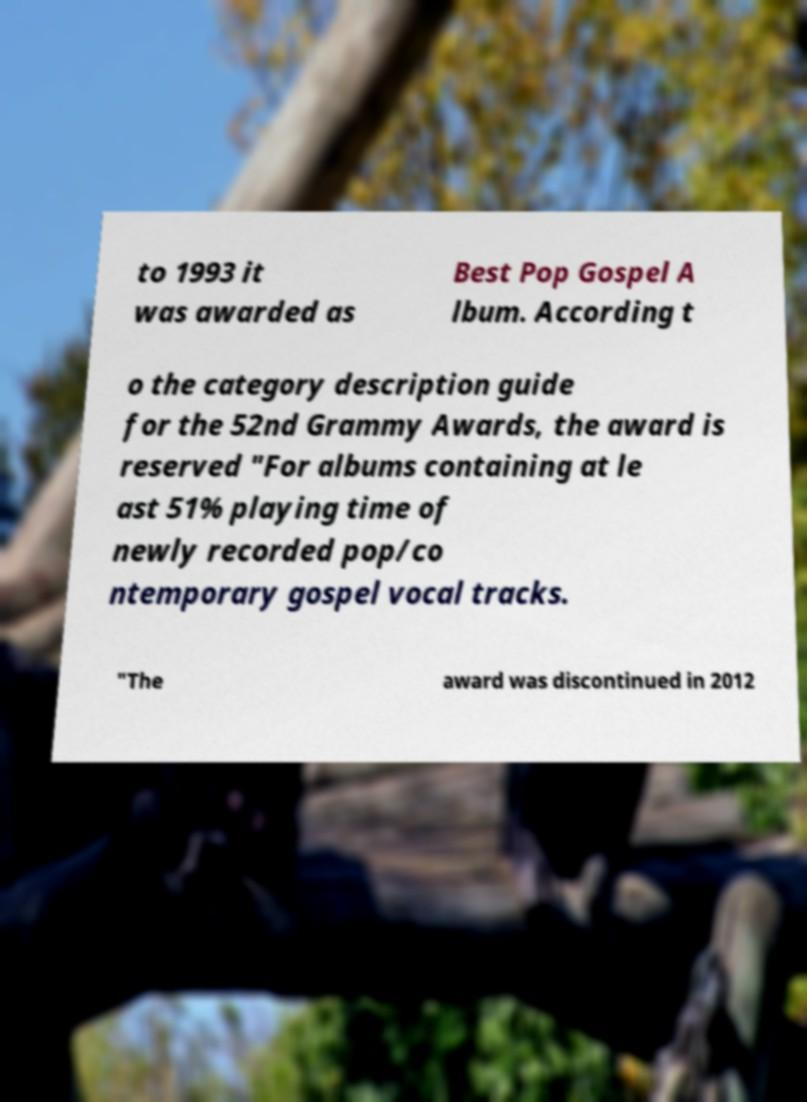I need the written content from this picture converted into text. Can you do that? to 1993 it was awarded as Best Pop Gospel A lbum. According t o the category description guide for the 52nd Grammy Awards, the award is reserved "For albums containing at le ast 51% playing time of newly recorded pop/co ntemporary gospel vocal tracks. "The award was discontinued in 2012 